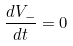Convert formula to latex. <formula><loc_0><loc_0><loc_500><loc_500>\frac { d V _ { - } } { d t } = 0</formula> 